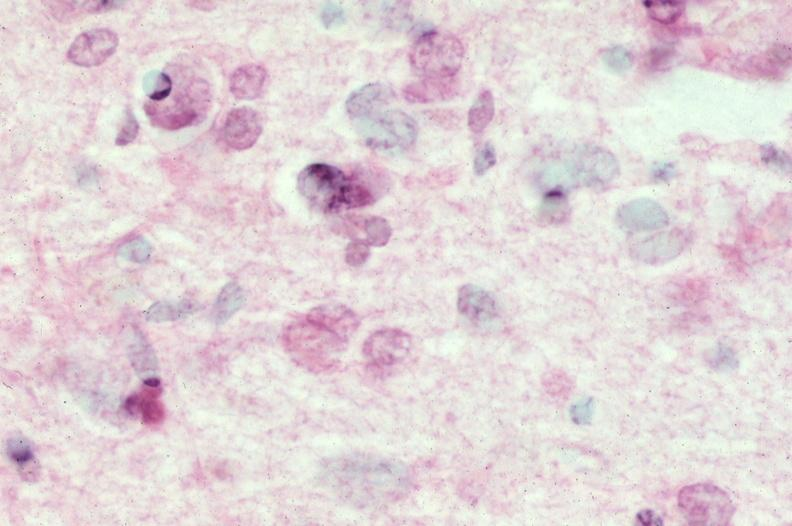s nervous present?
Answer the question using a single word or phrase. Yes 